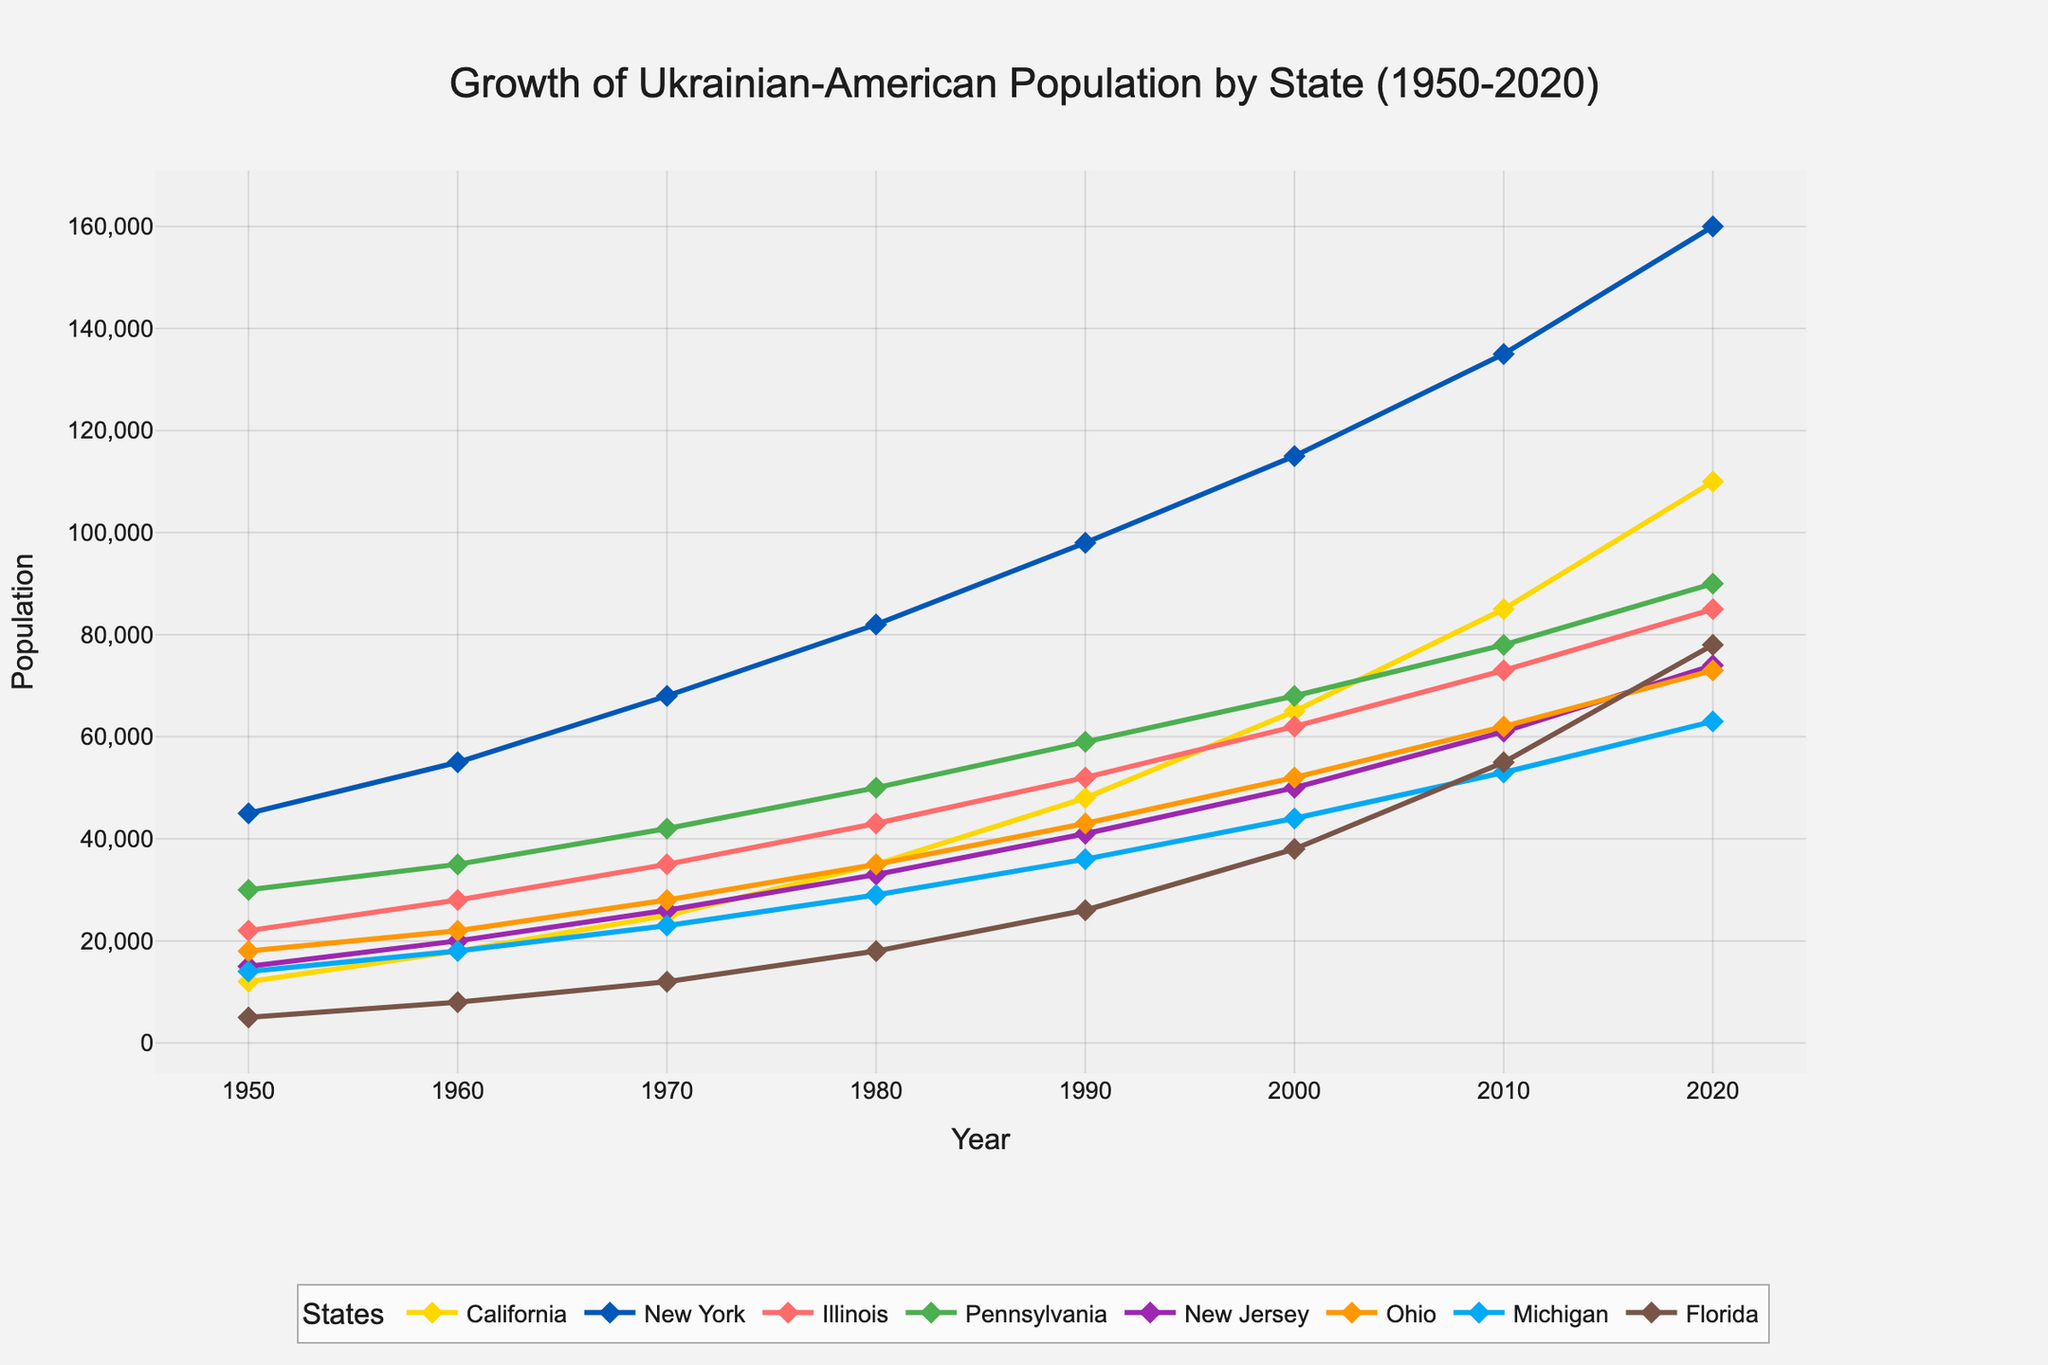What's the difference in Ukrainian-American population between California and New York in 2020? In 2020, the population in California was 110,000 and in New York was 160,000. So, the difference is 160,000 - 110,000.
Answer: 50,000 Which state saw the highest population growth from 1950 to 2020? By comparing the population increase in each state from 1950 to 2020: California (110,000 - 12,000 = 98,000), New York (160,000 - 45,000 = 115,000), Illinois (85,000 - 22,000 = 63,000), Pennsylvania (90,000 - 30,000 = 60,000), New Jersey (74,000 - 15,000 = 59,000), Ohio (73,000 - 18,000 = 55,000), Michigan (63,000 - 14,000 = 49,000), Florida (78,000 - 5,000 = 73,000). New York had the highest growth.
Answer: New York What is the average Ukrainian-American population in Ohio across all decades shown? The population values in Ohio are 18,000, 22,000, 28,000, 35,000, 43,000, 52,000, 62,000, and 73,000. The average is calculated as (18,000 + 22,000 + 28,000 + 35,000 + 43,000 + 52,000 + 62,000 + 73,000) / 8.
Answer: 41,625 Between which two consecutive decades did Illinois see the greatest increase in Ukrainian-American population? Looking at the differences: 1950 to 1960 (28,000 - 22,000 = 6,000), 1960 to 1970 (35,000 - 28,000 = 7,000), 1970 to 1980 (43,000 - 35,000 = 8,000), 1980 to 1990 (52,000 - 43,000 = 9,000), 1990 to 2000 (62,000 - 52,000 = 10,000), 2000 to 2010 (73,000 - 62,000 = 11,000), 2010 to 2020 (85,000 - 73,000 = 12,000). The greatest increase occurred between 2010 and 2020.
Answer: 2010 to 2020 Which state had the smallest population growth between 1950 and 2020? Calculating the growth for each state: California (98,000), New York (115,000), Illinois (63,000), Pennsylvania (60,000), New Jersey (59,000), Ohio (55,000), Michigan (49,000), Florida (73,000). Michigan had the smallest growth.
Answer: Michigan What was the total Ukrainian-American population across all states in 1980? Summing the populations in 1980: California (35,000), New York (82,000), Illinois (43,000), Pennsylvania (50,000), New Jersey (33,000), Ohio (35,000), Michigan (29,000), Florida (18,000). Total is 35,000 + 82,000 + 43,000 + 50,000 + 33,000 + 35,000 + 29,000 + 18,000.
Answer: 325,000 Which state had the highest population in 1970 and by how much was it greater than the state with the second-highest population? In 1970, New York had the highest population (68,000). The second highest was Pennsylvania (42,000). The difference is 68,000 - 42,000.
Answer: 26,000 What trend do you observe about the growth pattern of the Ukrainian-American population in Florida from 1950 to 2020? In Florida, the population increased from 5,000 in 1950 to 78,000 in 2020. The trend is a consistent increase every decade, showing significant growth, especially toward later decades.
Answer: Consistent increase Which state had a population of 61,000 in 2010, and what color is used to represent it in the figure? Referring to the data, New Jersey had a population of 61,000 in 2010. The color representing New Jersey in the figure is orange.
Answer: New Jersey, orange What was the Ukrainian-American population in Pennsylvania in 1950, 1980, and 2020, and what can be inferred from these values? In Pennsylvania, the population was 30,000 in 1950, 50,000 in 1980, and 90,000 in 2020. This shows a steady increase in each of these time points, indicating growth over the decades.
Answer: 30,000, 50,000, 90,000, steady increase 